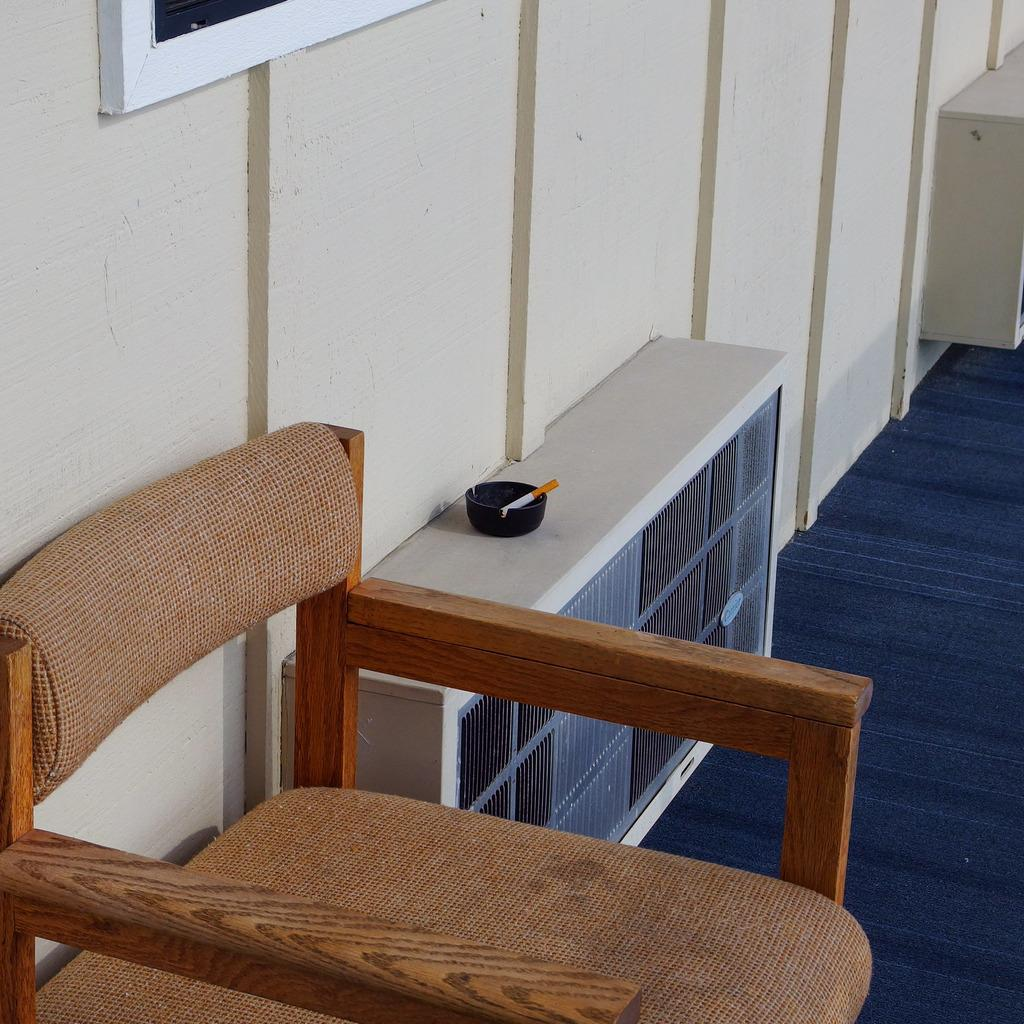What is located in the front of the image? There is a chair in the front of the image. What can be seen on the left side of the image? There is a wall on the left side of the image. What is in the middle of the image? There is a box in the middle of the image. What is on top of the box? There is an ashtray on the box. What is inside the ashtray? There is a cigar in the ashtray. What type of lumber is stacked on the wall in the image? There is no lumber stacked on the wall in the image; it only shows a chair, a wall, a box, an ashtray, and a cigar. What flavor of soda is being served in the image? There is no soda present in the image. What type of pancake is being eaten by the person in the image? There is no person or pancake present in the image. 